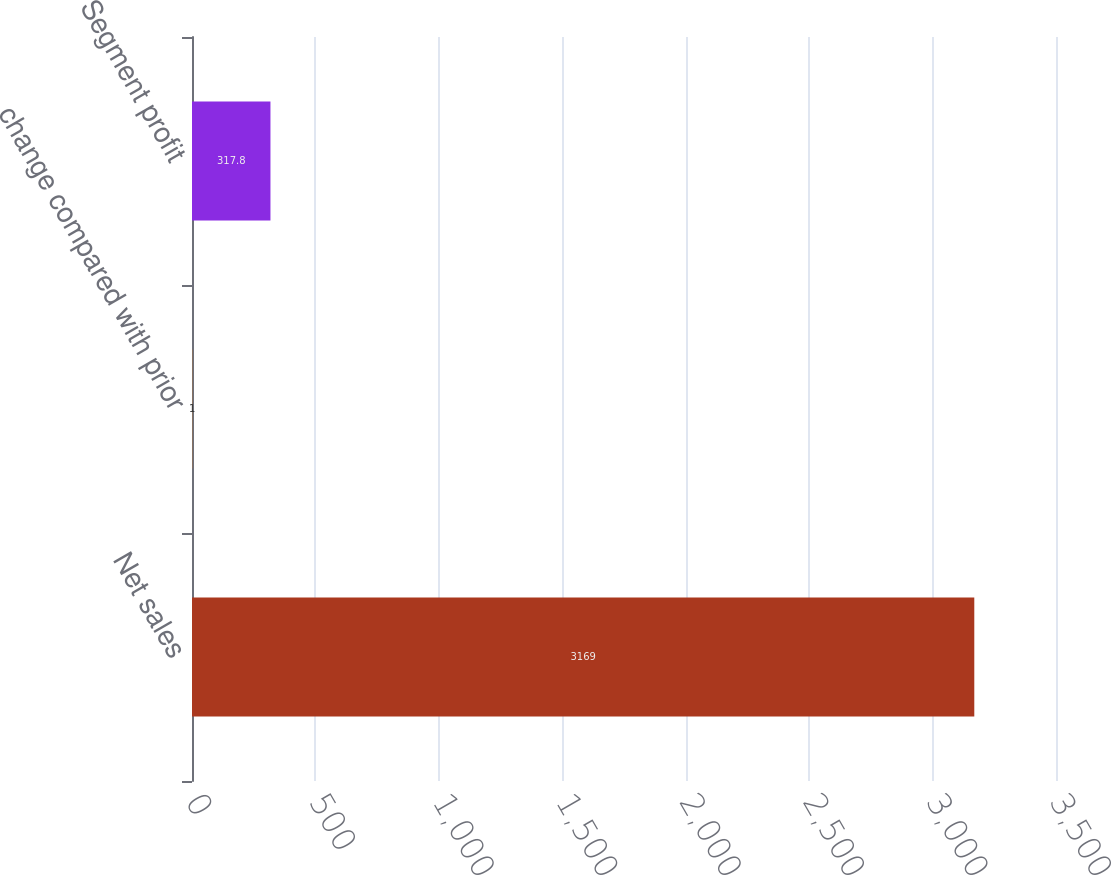Convert chart. <chart><loc_0><loc_0><loc_500><loc_500><bar_chart><fcel>Net sales<fcel>change compared with prior<fcel>Segment profit<nl><fcel>3169<fcel>1<fcel>317.8<nl></chart> 